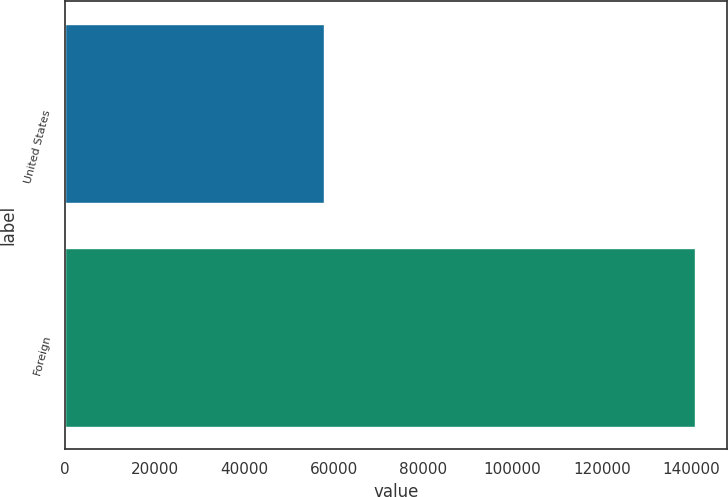<chart> <loc_0><loc_0><loc_500><loc_500><bar_chart><fcel>United States<fcel>Foreign<nl><fcel>57795<fcel>140863<nl></chart> 